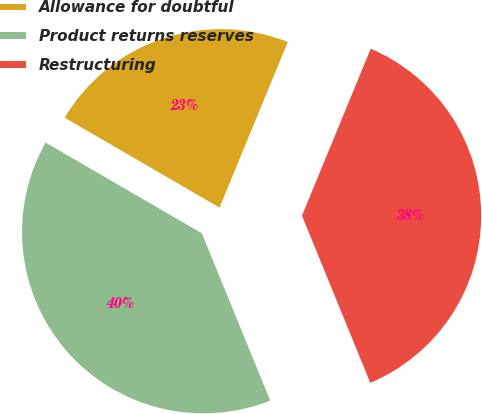<chart> <loc_0><loc_0><loc_500><loc_500><pie_chart><fcel>Allowance for doubtful<fcel>Product returns reserves<fcel>Restructuring<nl><fcel>22.84%<fcel>39.55%<fcel>37.6%<nl></chart> 